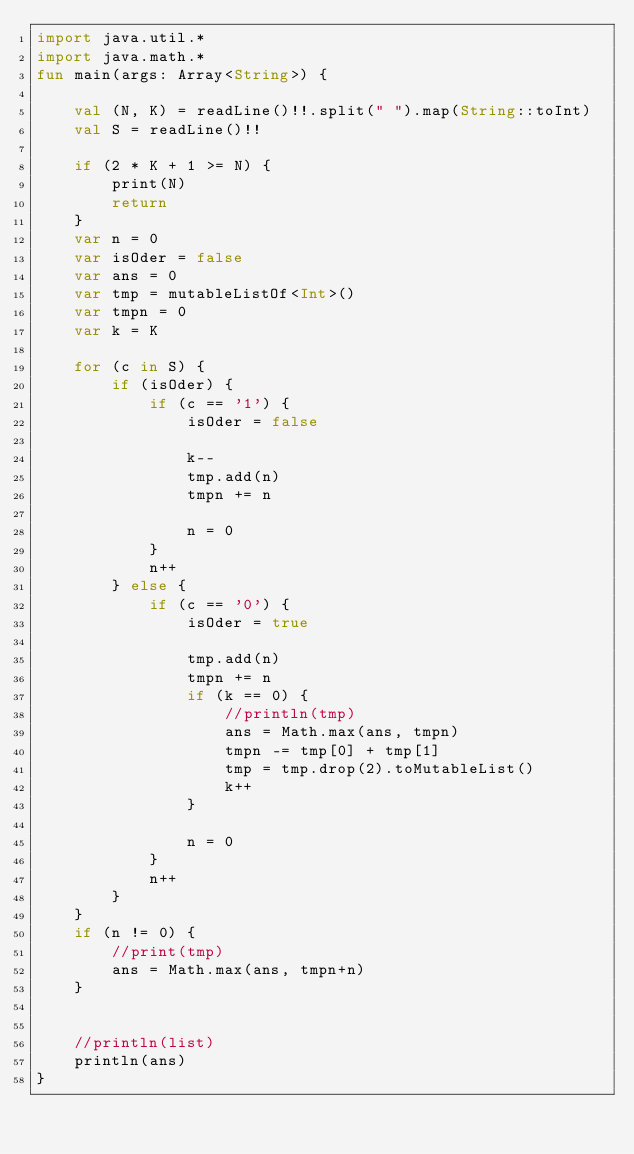<code> <loc_0><loc_0><loc_500><loc_500><_Kotlin_>import java.util.*
import java.math.*
fun main(args: Array<String>) {

    val (N, K) = readLine()!!.split(" ").map(String::toInt)
    val S = readLine()!!

    if (2 * K + 1 >= N) {
        print(N)
        return
    }
    var n = 0
    var isOder = false
    var ans = 0
    var tmp = mutableListOf<Int>()
    var tmpn = 0
    var k = K

    for (c in S) {
        if (isOder) {
            if (c == '1') {
                isOder = false

                k--
                tmp.add(n)
                tmpn += n

                n = 0
            }
            n++
        } else {
            if (c == '0') {
                isOder = true

                tmp.add(n)
                tmpn += n
                if (k == 0) {
                    //println(tmp)
                    ans = Math.max(ans, tmpn)
                    tmpn -= tmp[0] + tmp[1]
                    tmp = tmp.drop(2).toMutableList()
                    k++
                }

                n = 0
            }
            n++
        }
    }
    if (n != 0) {
        //print(tmp)
        ans = Math.max(ans, tmpn+n)
    }


    //println(list)
    println(ans)
}</code> 